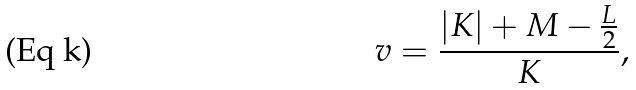<formula> <loc_0><loc_0><loc_500><loc_500>v = \frac { | K | + M - \frac { L } { 2 } } { K } ,</formula> 